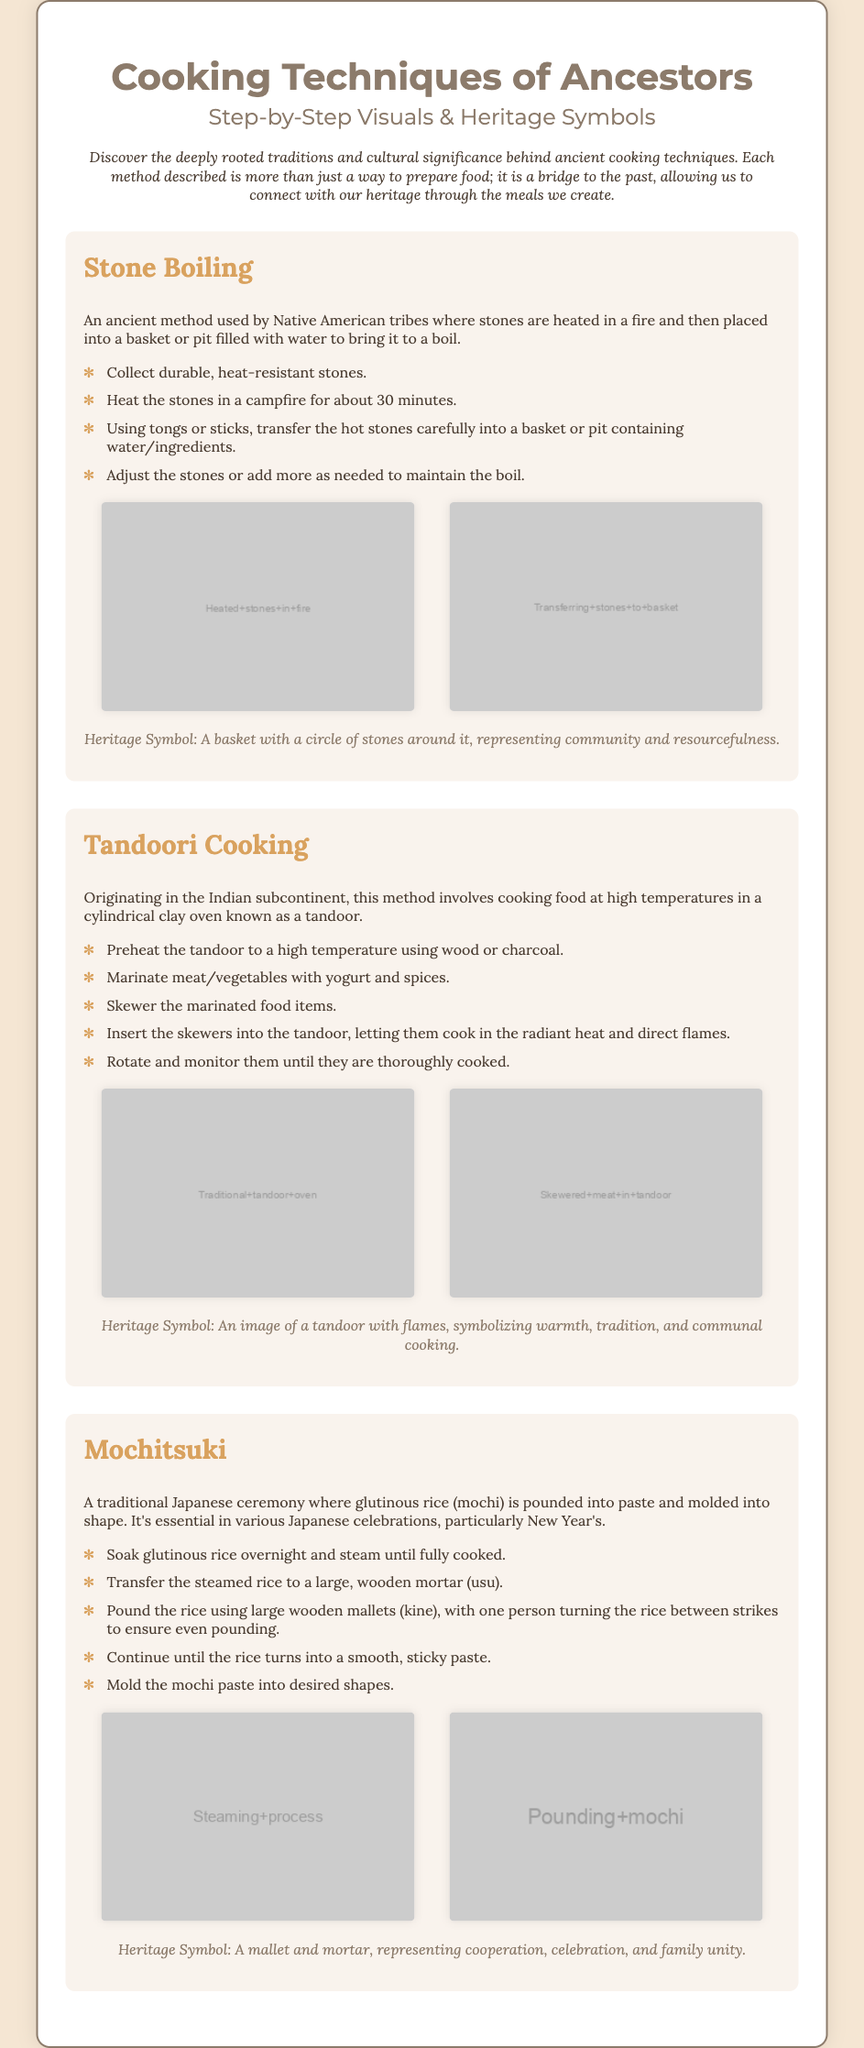What is the title of the document? The title of the document is presented prominently at the top, which is "Cooking Techniques of Ancestors."
Answer: Cooking Techniques of Ancestors What ancient method is used by Native American tribes? The method described that is used by Native American tribes is mentioned as "Stone Boiling."
Answer: Stone Boiling How many steps are there for the technique of Mochitsuki? The number of steps provided for the technique of Mochitsuki is listed as five.
Answer: 5 What is the heritage symbol for Tandoori Cooking? The document specifies that the heritage symbol for Tandoori Cooking is "An image of a tandoor with flames."
Answer: An image of a tandoor with flames What type of oven is used in Tandoori Cooking? The document refers to the cooking method mentioning the use of a "cylindrical clay oven known as a tandoor."
Answer: tandoor Which technique involves pounding glutinous rice? The technique that involves pounding glutinous rice is referred to as "Mochitsuki."
Answer: Mochitsuki What do the heated stones represent in the heritage symbol? The heritage symbol description indicates that it represents "community and resourcefulness."
Answer: community and resourcefulness How is the rice prepared in Mochitsuki before pounding? The document states that the rice is soaked overnight and then steamed before it is pounded.
Answer: steamed 